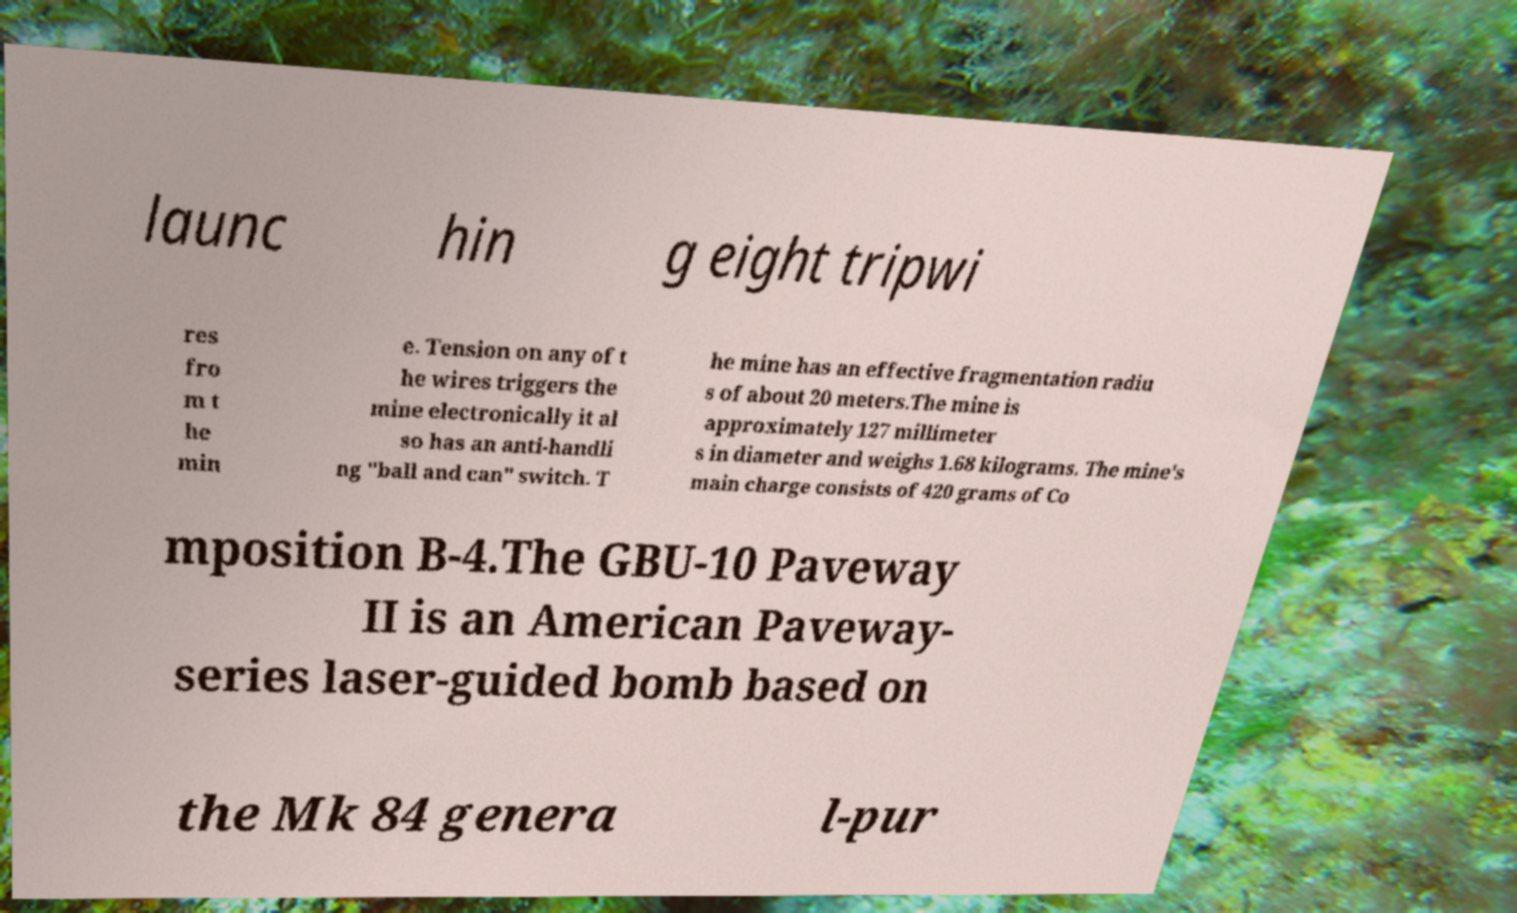Can you read and provide the text displayed in the image?This photo seems to have some interesting text. Can you extract and type it out for me? launc hin g eight tripwi res fro m t he min e. Tension on any of t he wires triggers the mine electronically it al so has an anti-handli ng "ball and can" switch. T he mine has an effective fragmentation radiu s of about 20 meters.The mine is approximately 127 millimeter s in diameter and weighs 1.68 kilograms. The mine's main charge consists of 420 grams of Co mposition B-4.The GBU-10 Paveway II is an American Paveway- series laser-guided bomb based on the Mk 84 genera l-pur 